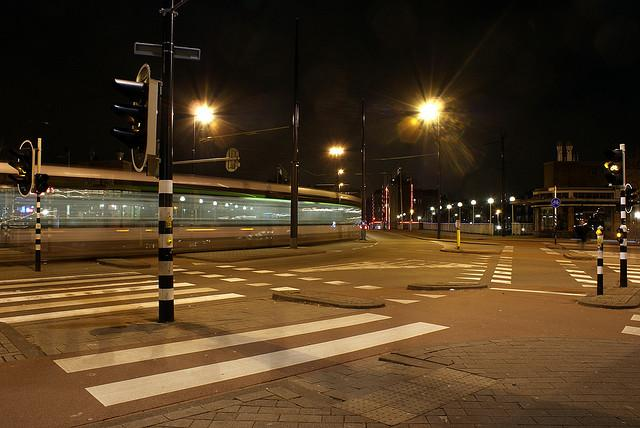What time of day is shown here?

Choices:
A) late night
B) 9 am
C) noon
D) 5 pm late night 